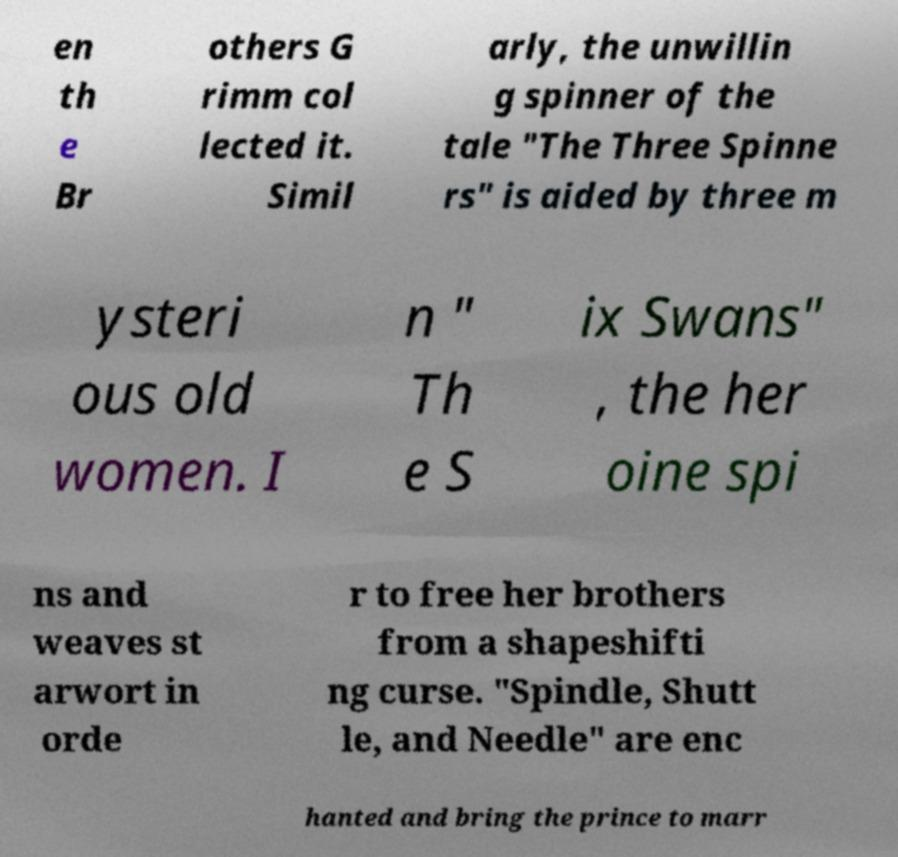Please read and relay the text visible in this image. What does it say? en th e Br others G rimm col lected it. Simil arly, the unwillin g spinner of the tale "The Three Spinne rs" is aided by three m ysteri ous old women. I n " Th e S ix Swans" , the her oine spi ns and weaves st arwort in orde r to free her brothers from a shapeshifti ng curse. "Spindle, Shutt le, and Needle" are enc hanted and bring the prince to marr 